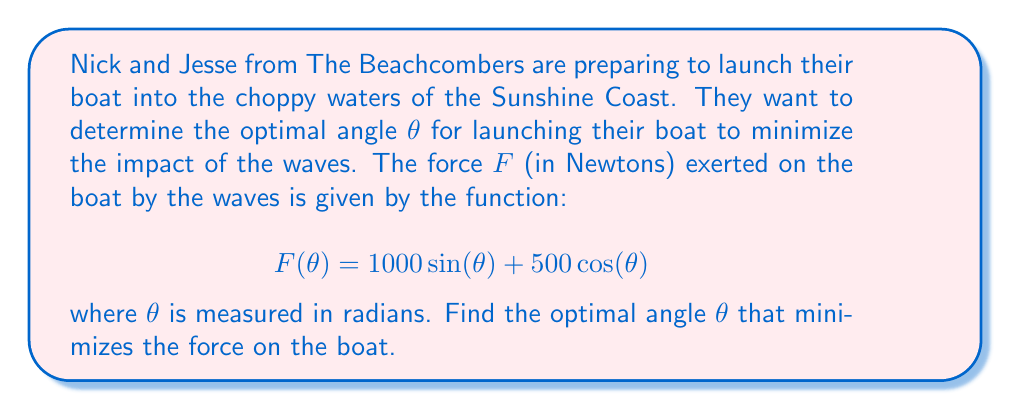Help me with this question. To find the optimal angle that minimizes the force, we need to find the minimum of the function F(θ). We can do this by following these steps:

1. Take the derivative of F(θ) with respect to θ:
   $$F'(\theta) = 1000 \cos(\theta) - 500 \sin(\theta)$$

2. Set the derivative equal to zero to find the critical points:
   $$1000 \cos(\theta) - 500 \sin(\theta) = 0$$

3. Divide both sides by 500:
   $$2 \cos(\theta) - \sin(\theta) = 0$$

4. Use the tangent half-angle substitution:
   Let $u = \tan(\frac{\theta}{2})$, then:
   $$\cos(\theta) = \frac{1-u^2}{1+u^2}$$ and $$\sin(\theta) = \frac{2u}{1+u^2}$$

5. Substitute these into the equation:
   $$2(\frac{1-u^2}{1+u^2}) - \frac{2u}{1+u^2} = 0$$

6. Multiply both sides by $(1+u^2)$:
   $$2(1-u^2) - 2u = 0$$

7. Expand:
   $$2 - 2u^2 - 2u = 0$$

8. Rearrange:
   $$2u^2 + 2u - 2 = 0$$

9. Solve this quadratic equation:
   $$u = \frac{-1 \pm \sqrt{1^2 - 4(1)(-1)}}{2(1)} = \frac{-1 \pm \sqrt{5}}{2}$$

10. We only need the positive solution:
    $$u = \frac{-1 + \sqrt{5}}{2}$$

11. Remember that $u = \tan(\frac{\theta}{2})$, so:
    $$\theta = 2 \arctan(\frac{-1 + \sqrt{5}}{2})$$

12. Calculate this value:
    $$\theta \approx 0.9273 \text{ radians} \approx 53.13°$$

To confirm this is a minimum, we can check the second derivative is positive at this point.
Answer: $\theta \approx 0.9273 \text{ radians}$ or $53.13°$ 